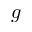Convert formula to latex. <formula><loc_0><loc_0><loc_500><loc_500>g</formula> 